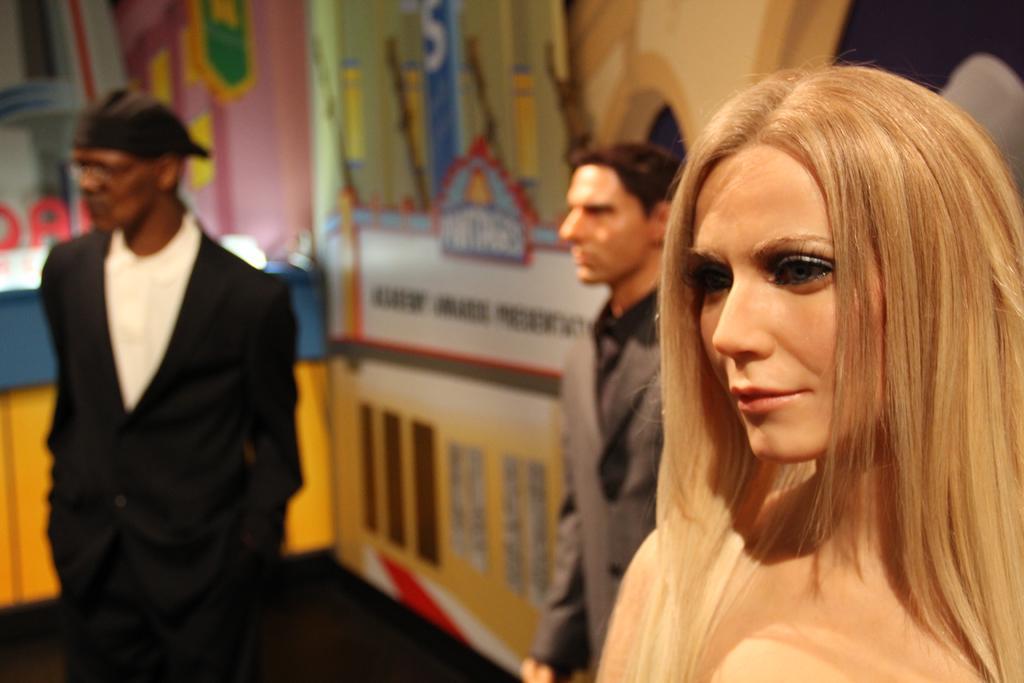In one or two sentences, can you explain what this image depicts? On the right there is a woman statue, besides her we can see a person statue who is wearing suit. On the left we can see a black color statue who is wearing cap and blazer. On the background we can see a colorful wall. 